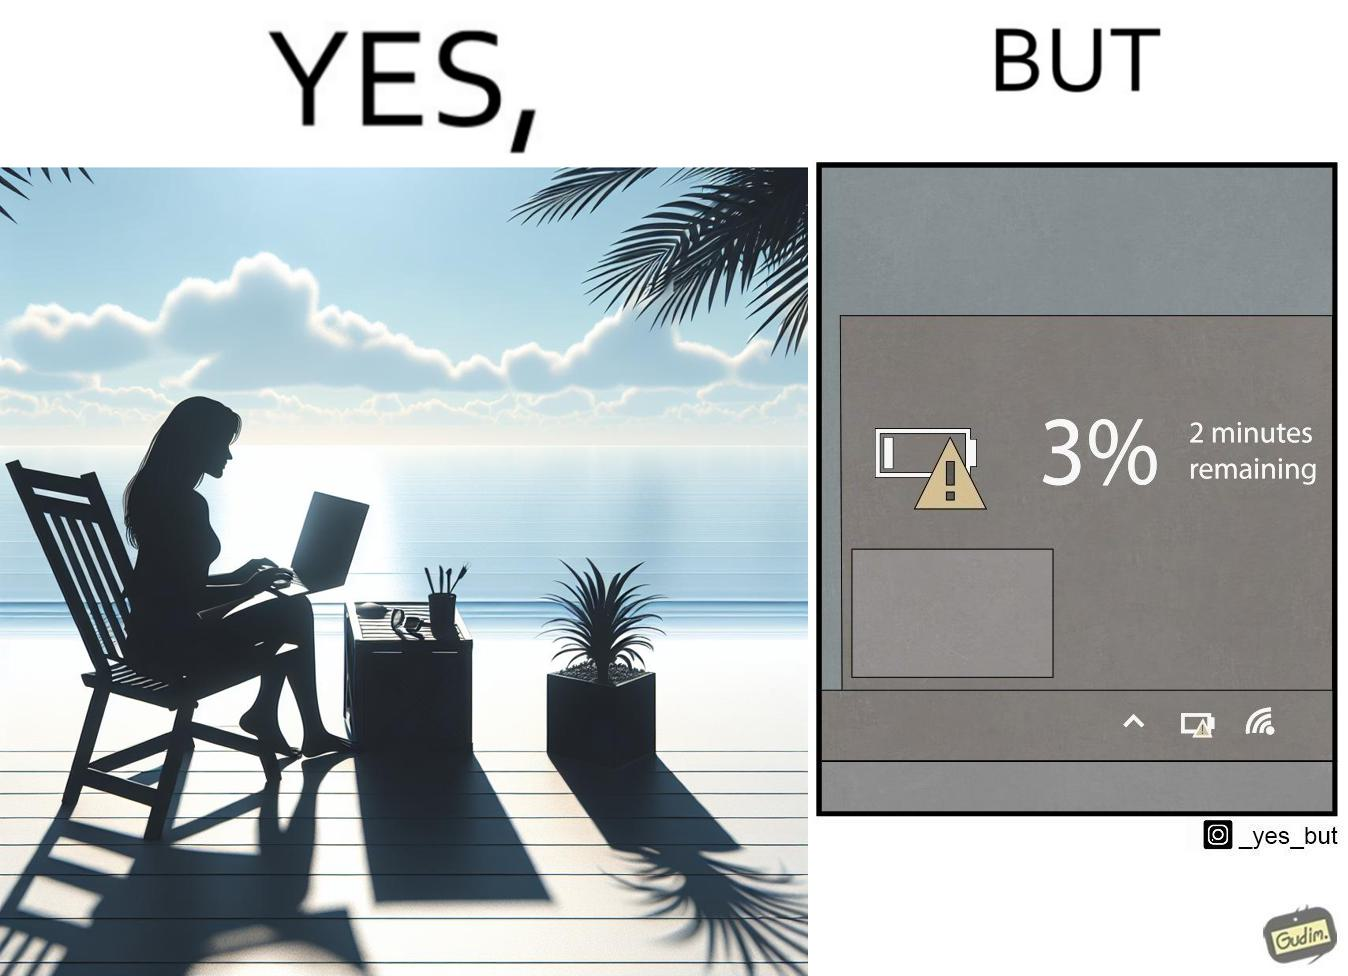Describe the content of this image. The image is ironical, as a person is working on a laptop in a beach, which looks like a soothing and calm environment to work. However, the laptop is about to get discharged, and there is probably no electric supply to keep the laptop open while working on the beach, turning the situation into an inconvenience. 